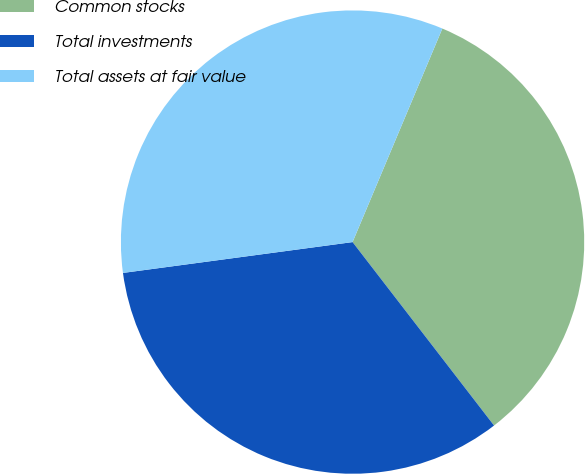Convert chart. <chart><loc_0><loc_0><loc_500><loc_500><pie_chart><fcel>Common stocks<fcel>Total investments<fcel>Total assets at fair value<nl><fcel>33.21%<fcel>33.33%<fcel>33.46%<nl></chart> 